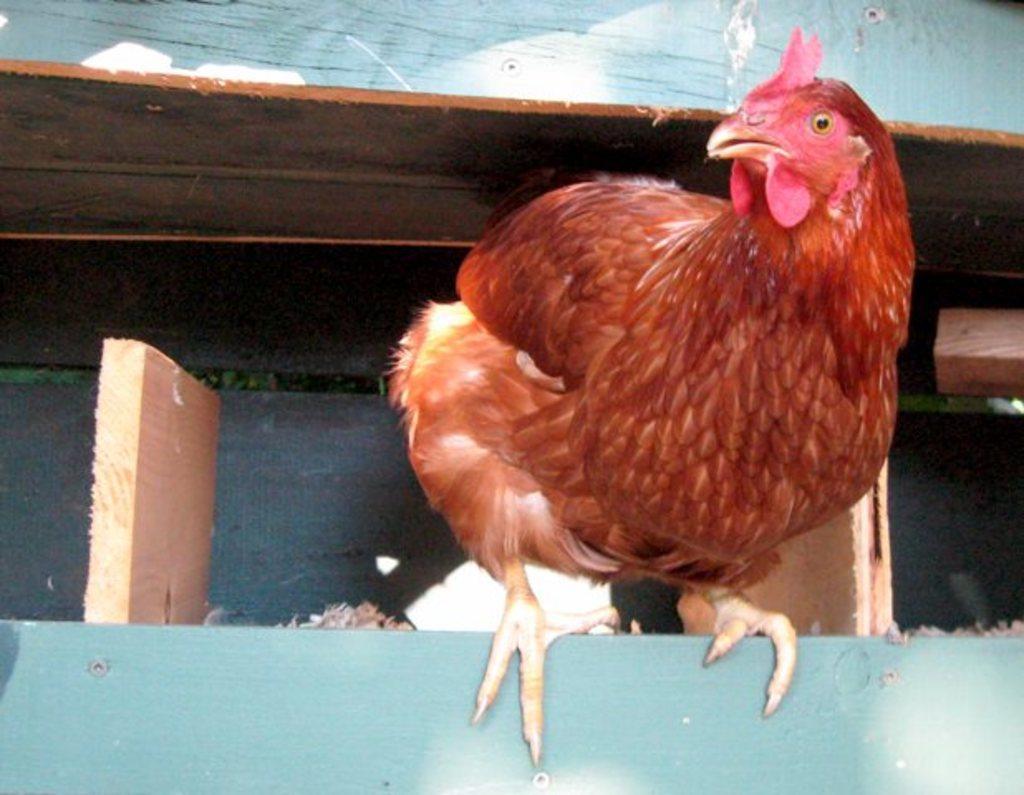How would you summarize this image in a sentence or two? In this picture, we can see a hen on the wooden surface, we can see some wooden objects, and background. 